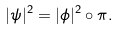<formula> <loc_0><loc_0><loc_500><loc_500>| \psi | ^ { 2 } = | \phi | ^ { 2 } \circ \pi .</formula> 